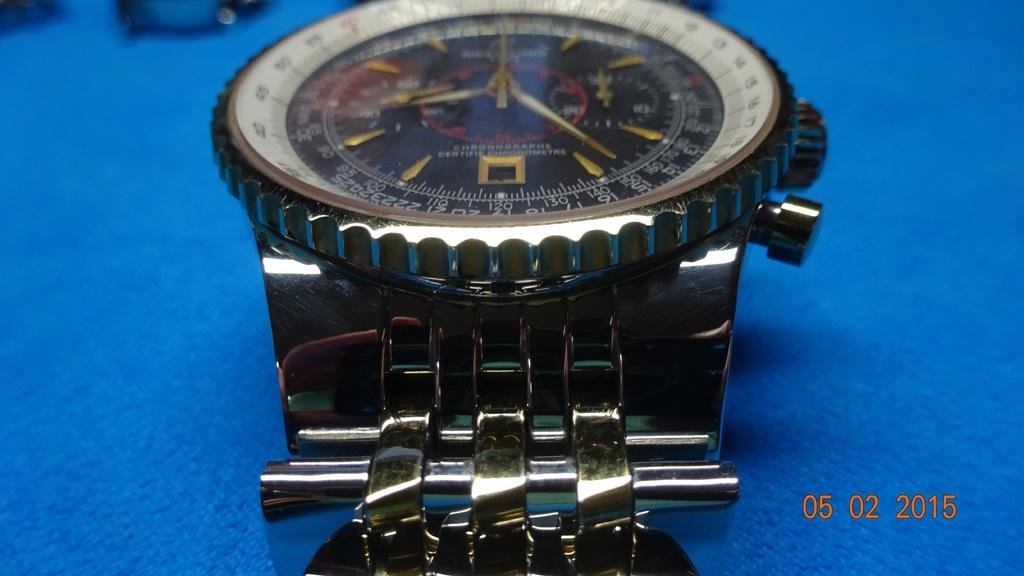What object is in the image that is used for telling time? There is a wristwatch in the image that is used for telling time. Where is the wristwatch located in the image? The wristwatch is on a table in the image. What color is the cloth covering the table in the image? The table is covered with a blue cloth in the image. What material is the wristwatch made of? The wristwatch is made of metal. How much wealth is displayed on the wristwatch in the image? The image does not provide any information about the value or wealth associated with the wristwatch. 